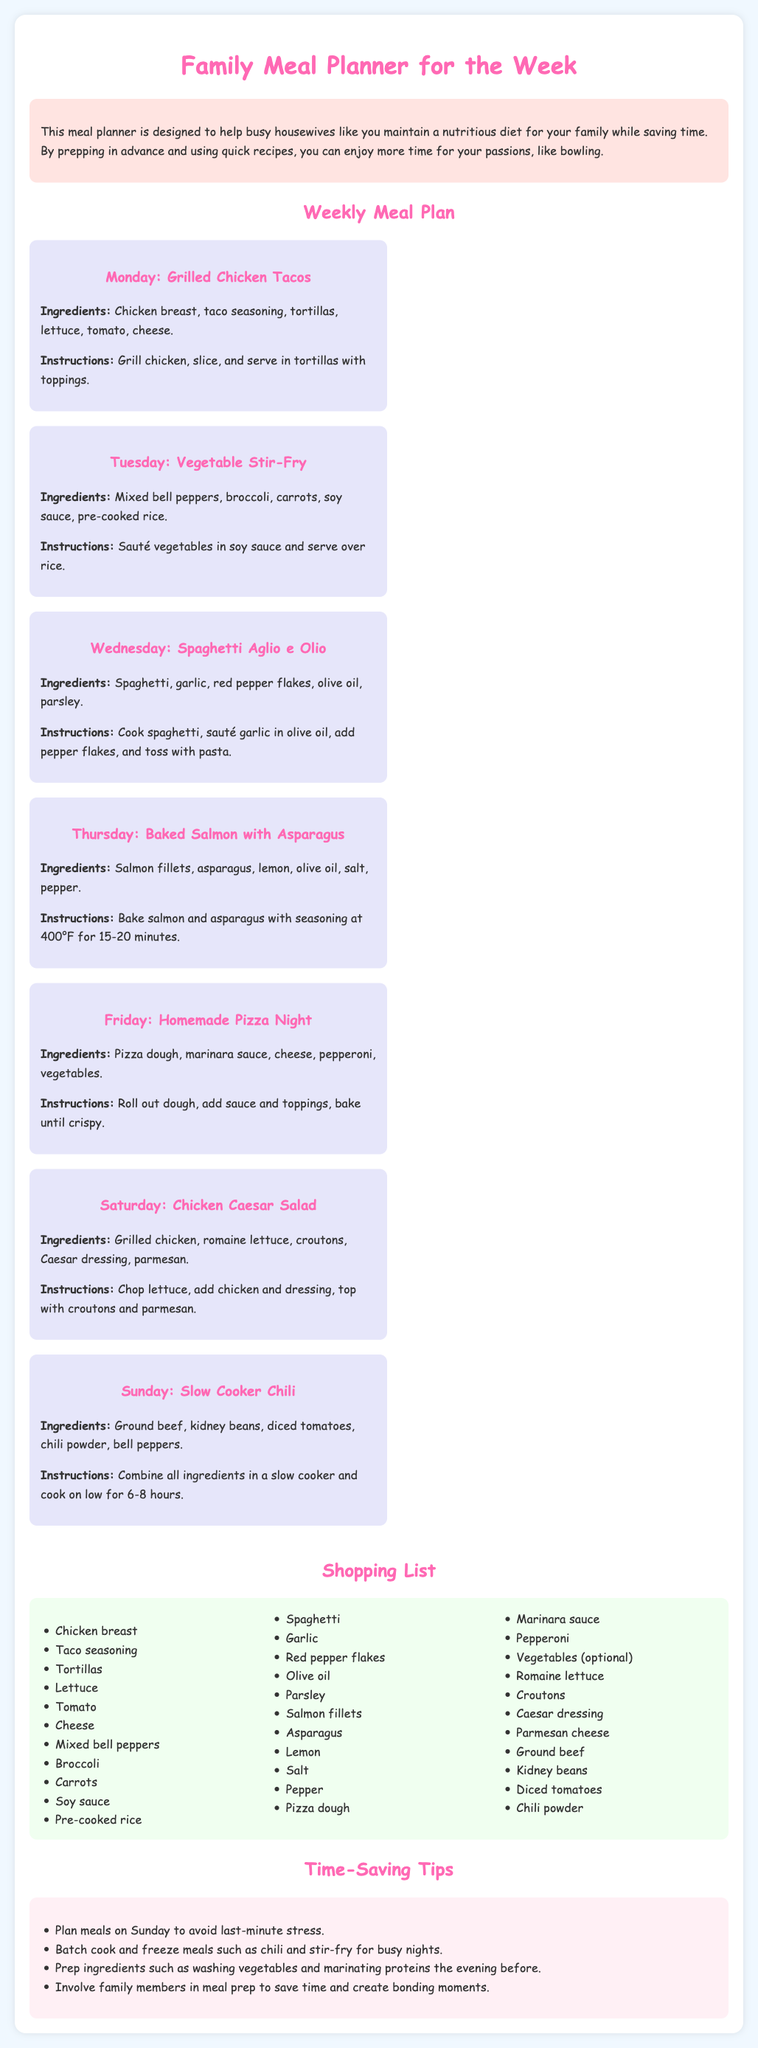What is the first meal planned for Monday? The first meal is listed under Monday in the meal plan section.
Answer: Grilled Chicken Tacos How many ingredients are listed for Tuesday's meal? The total number of ingredients for Tuesday's Vegetable Stir-Fry can be counted from the provided list.
Answer: 5 What cooking method is used for the Thursday meal? The cooking method for Thursday's meal can be found in the instructions for Baked Salmon with Asparagus.
Answer: Bake Which meal requires a slow cooker? This can be determined by identifying which meal's instructions mention a slow cooker.
Answer: Slow Cooker Chili What ingredient is used in both Monday and Saturday meals? The document includes ingredients listed for both meals, which can be compared.
Answer: Chicken How long should the salmon be baked? This information is found in the instructions for Thursday's meal regarding baking time.
Answer: 15-20 minutes What is a time-saving tip mentioned in the document? This can be found in the Time-Saving Tips section, which lists specific suggestions for busy housewives.
Answer: Batch cook and freeze meals What type of sauce is used in Tuesday's meal? The type of sauce is specified in the ingredients for Vegetable Stir-Fry under Tuesday's meal.
Answer: Soy sauce 